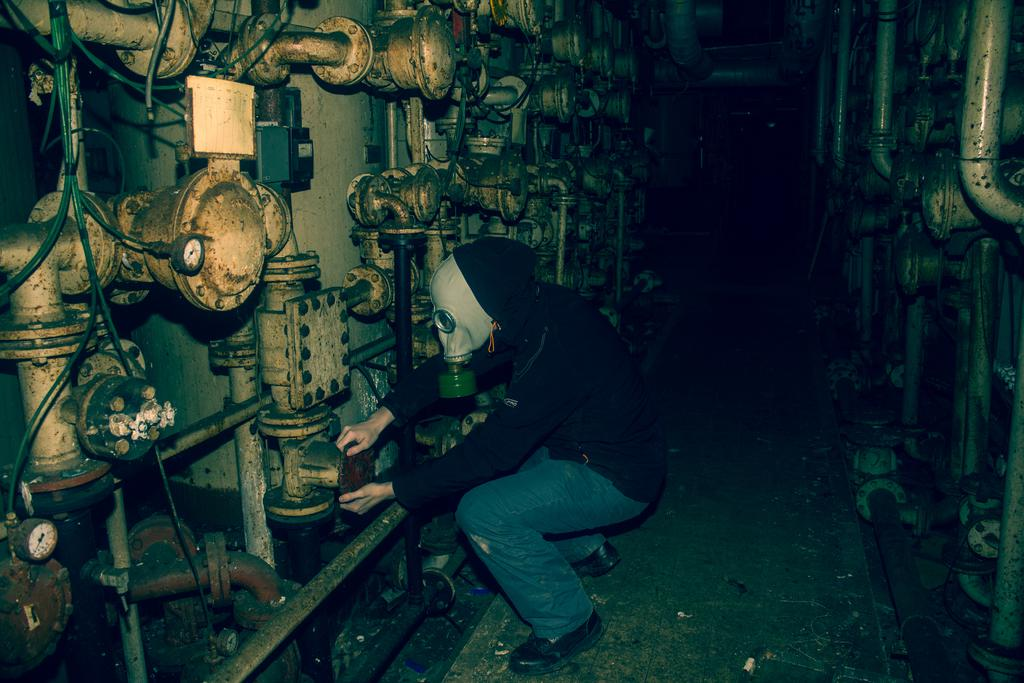What type of room is the image taken in? The image is taken inside a control room. Can you describe the person in the image? The person in the image is wearing a black jacket and a mask. What position is the person in? The person is in a squat position. What is the person holding in the image? The person is holding a regulator. What type of boundary or limit can be seen in the image? There is no boundary or limit visible in the image; it features a person in a control room holding a regulator. Can you hear the person's voice in the image? The image is a still photograph, so it does not capture any sound or voice. 